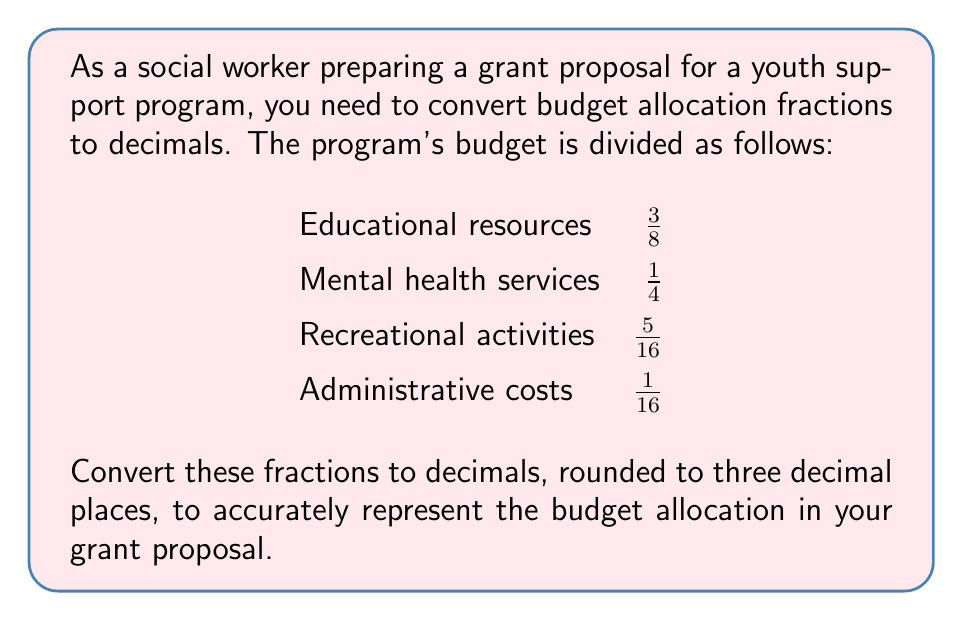Show me your answer to this math problem. To convert fractions to decimals, we divide the numerator by the denominator and round to three decimal places:

1. Educational resources ($\frac{3}{8}$):
   $$\frac{3}{8} = 3 \div 8 = 0.375$$

2. Mental health services ($\frac{1}{4}$):
   $$\frac{1}{4} = 1 \div 4 = 0.250$$

3. Recreational activities ($\frac{5}{16}$):
   $$\frac{5}{16} = 5 \div 16 = 0.3125 \approx 0.313$$ (rounded to three decimal places)

4. Administrative costs ($\frac{1}{16}$):
   $$\frac{1}{16} = 1 \div 16 = 0.0625 \approx 0.063$$ (rounded to three decimal places)

To verify, we can add these decimals:
$$0.375 + 0.250 + 0.313 + 0.063 = 1.001$$

The small discrepancy (0.001) is due to rounding.
Answer: 0.375, 0.250, 0.313, 0.063 